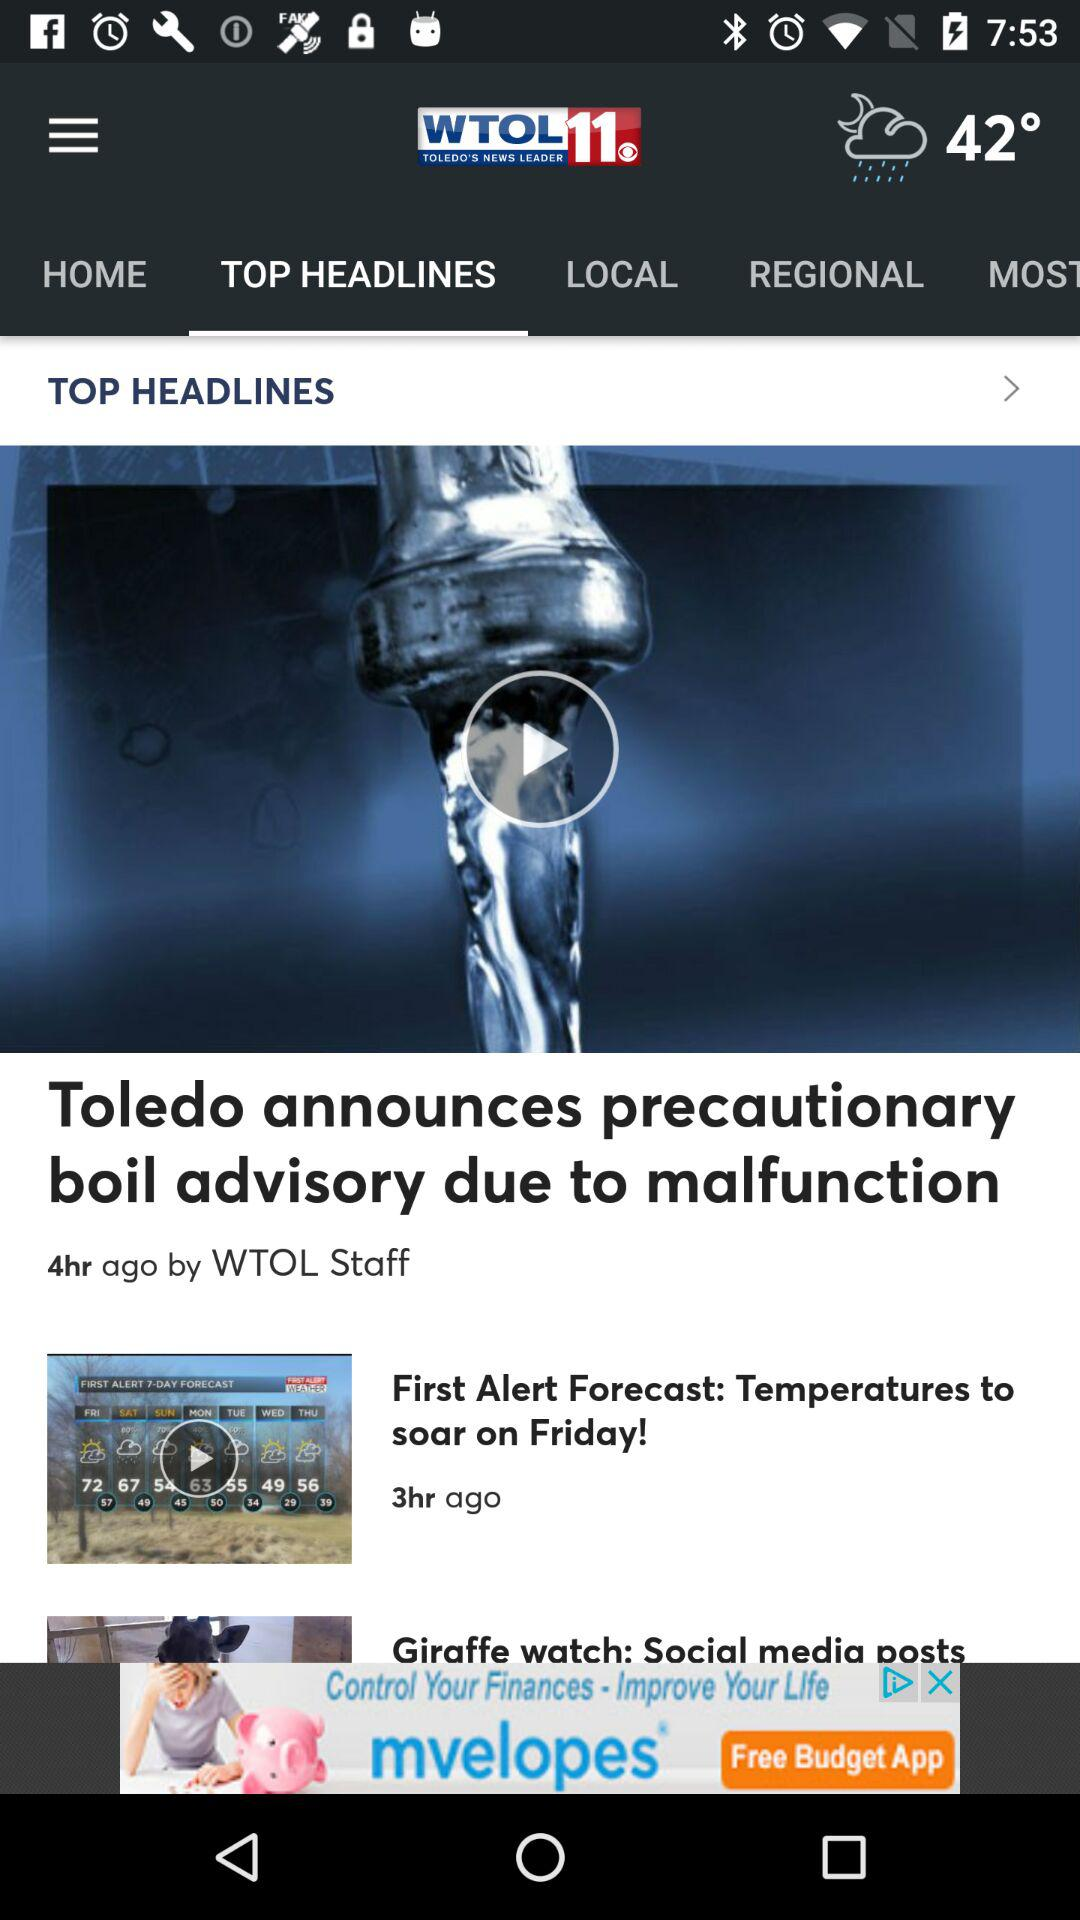When was the video of "First Alert Forecast" posted? The video of "First Alert Forecast" was posted 3 hours ago. 